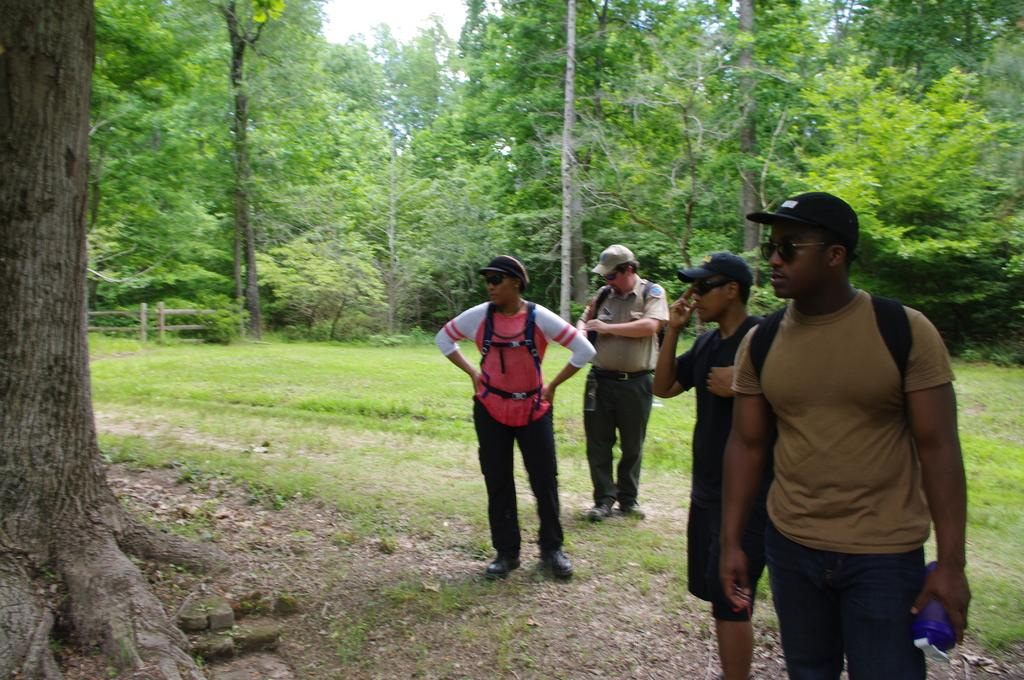What are the people in the image doing? The people in the image are standing on the ground. What can be seen in the background of the image? There are trees and a wooden fence in the background of the image. What is visible in the sky in the image? The sky is visible in the background of the image. What type of bomb can be seen exploding in the image? There is no bomb present in the image; it only features people standing on the ground, trees, a wooden fence, and the sky. 